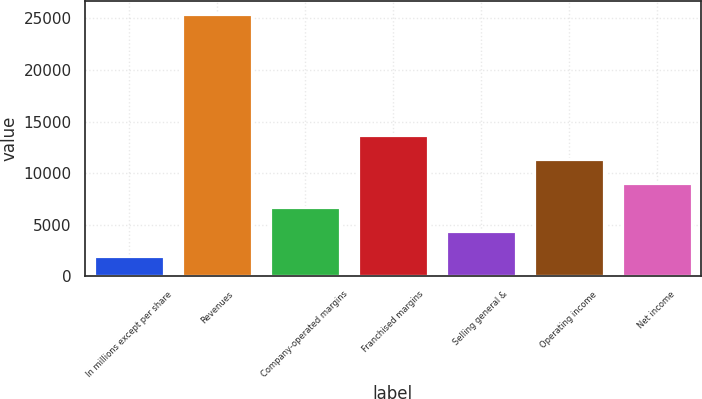Convert chart. <chart><loc_0><loc_0><loc_500><loc_500><bar_chart><fcel>In millions except per share<fcel>Revenues<fcel>Company-operated margins<fcel>Franchised margins<fcel>Selling general &<fcel>Operating income<fcel>Net income<nl><fcel>2015<fcel>25413<fcel>6694.6<fcel>13714<fcel>4354.8<fcel>11374.2<fcel>9034.4<nl></chart> 